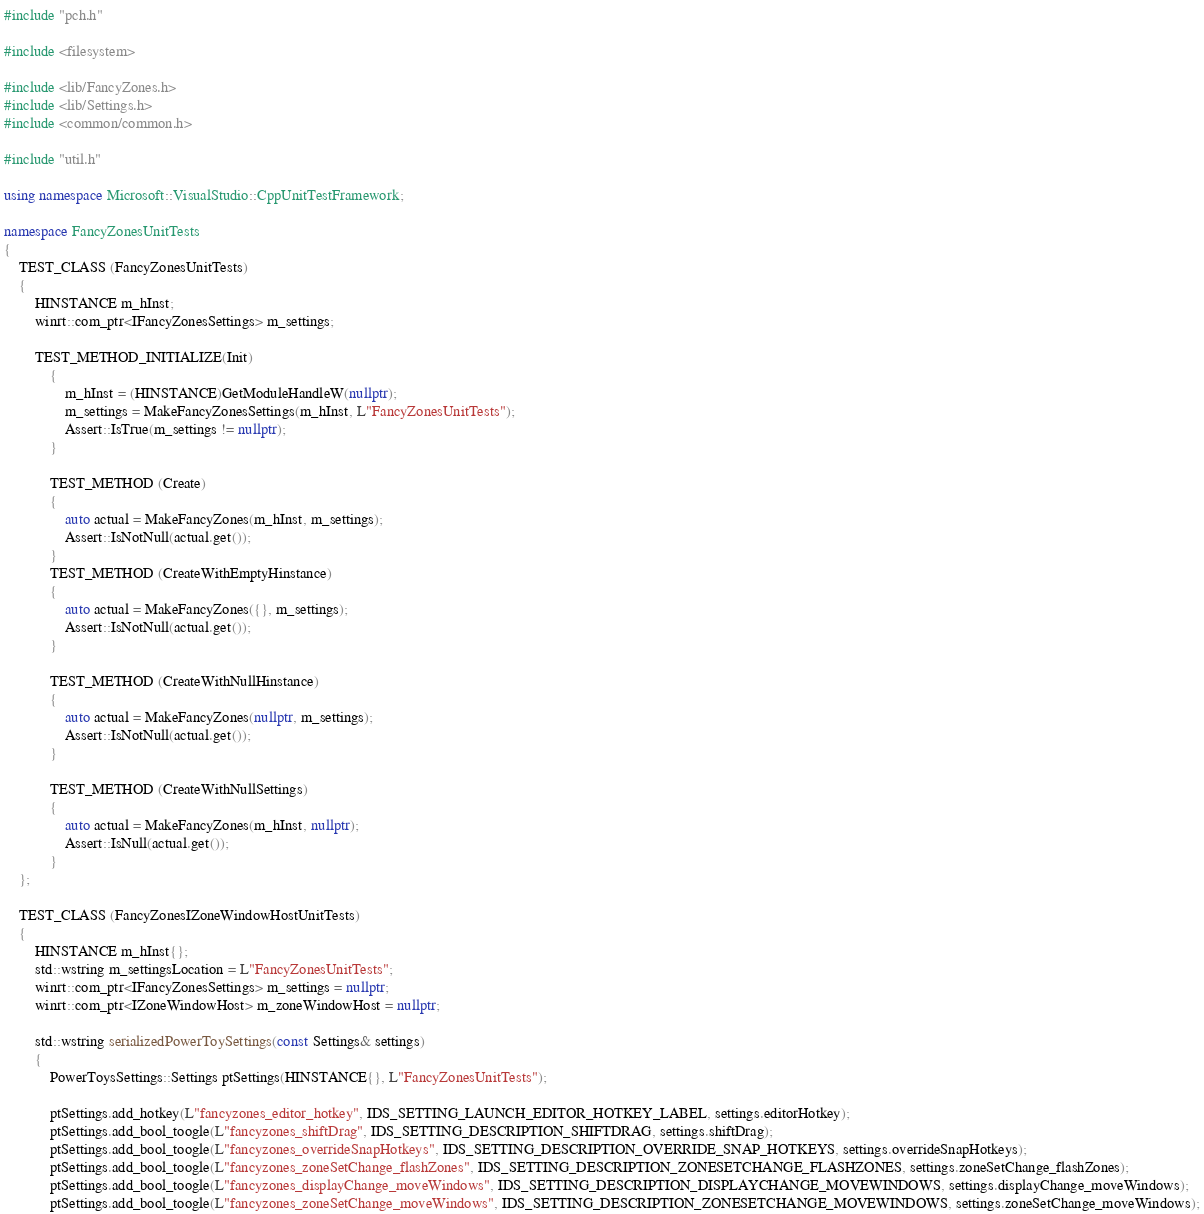<code> <loc_0><loc_0><loc_500><loc_500><_C++_>#include "pch.h"

#include <filesystem>

#include <lib/FancyZones.h>
#include <lib/Settings.h>
#include <common/common.h>

#include "util.h"

using namespace Microsoft::VisualStudio::CppUnitTestFramework;

namespace FancyZonesUnitTests
{
    TEST_CLASS (FancyZonesUnitTests)
    {
        HINSTANCE m_hInst;
        winrt::com_ptr<IFancyZonesSettings> m_settings;

        TEST_METHOD_INITIALIZE(Init)
            {
                m_hInst = (HINSTANCE)GetModuleHandleW(nullptr);
                m_settings = MakeFancyZonesSettings(m_hInst, L"FancyZonesUnitTests");
                Assert::IsTrue(m_settings != nullptr);
            }

            TEST_METHOD (Create)
            {
                auto actual = MakeFancyZones(m_hInst, m_settings);
                Assert::IsNotNull(actual.get());
            }
            TEST_METHOD (CreateWithEmptyHinstance)
            {
                auto actual = MakeFancyZones({}, m_settings);
                Assert::IsNotNull(actual.get());
            }

            TEST_METHOD (CreateWithNullHinstance)
            {
                auto actual = MakeFancyZones(nullptr, m_settings);
                Assert::IsNotNull(actual.get());
            }

            TEST_METHOD (CreateWithNullSettings)
            {
                auto actual = MakeFancyZones(m_hInst, nullptr);
                Assert::IsNull(actual.get());
            }
    };

    TEST_CLASS (FancyZonesIZoneWindowHostUnitTests)
    {
        HINSTANCE m_hInst{};
        std::wstring m_settingsLocation = L"FancyZonesUnitTests";
        winrt::com_ptr<IFancyZonesSettings> m_settings = nullptr;
        winrt::com_ptr<IZoneWindowHost> m_zoneWindowHost = nullptr;

        std::wstring serializedPowerToySettings(const Settings& settings)
        {
            PowerToysSettings::Settings ptSettings(HINSTANCE{}, L"FancyZonesUnitTests");

            ptSettings.add_hotkey(L"fancyzones_editor_hotkey", IDS_SETTING_LAUNCH_EDITOR_HOTKEY_LABEL, settings.editorHotkey);
            ptSettings.add_bool_toogle(L"fancyzones_shiftDrag", IDS_SETTING_DESCRIPTION_SHIFTDRAG, settings.shiftDrag);
            ptSettings.add_bool_toogle(L"fancyzones_overrideSnapHotkeys", IDS_SETTING_DESCRIPTION_OVERRIDE_SNAP_HOTKEYS, settings.overrideSnapHotkeys);
            ptSettings.add_bool_toogle(L"fancyzones_zoneSetChange_flashZones", IDS_SETTING_DESCRIPTION_ZONESETCHANGE_FLASHZONES, settings.zoneSetChange_flashZones);
            ptSettings.add_bool_toogle(L"fancyzones_displayChange_moveWindows", IDS_SETTING_DESCRIPTION_DISPLAYCHANGE_MOVEWINDOWS, settings.displayChange_moveWindows);
            ptSettings.add_bool_toogle(L"fancyzones_zoneSetChange_moveWindows", IDS_SETTING_DESCRIPTION_ZONESETCHANGE_MOVEWINDOWS, settings.zoneSetChange_moveWindows);</code> 